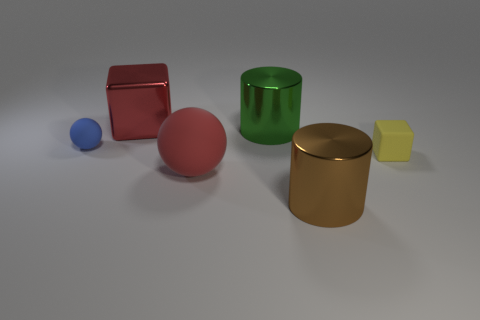Subtract all cyan blocks. Subtract all red spheres. How many blocks are left? 2 Add 3 large red blocks. How many objects exist? 9 Subtract all blocks. How many objects are left? 4 Add 4 large cylinders. How many large cylinders exist? 6 Subtract 1 yellow cubes. How many objects are left? 5 Subtract all big brown shiny objects. Subtract all brown objects. How many objects are left? 4 Add 2 brown metal cylinders. How many brown metal cylinders are left? 3 